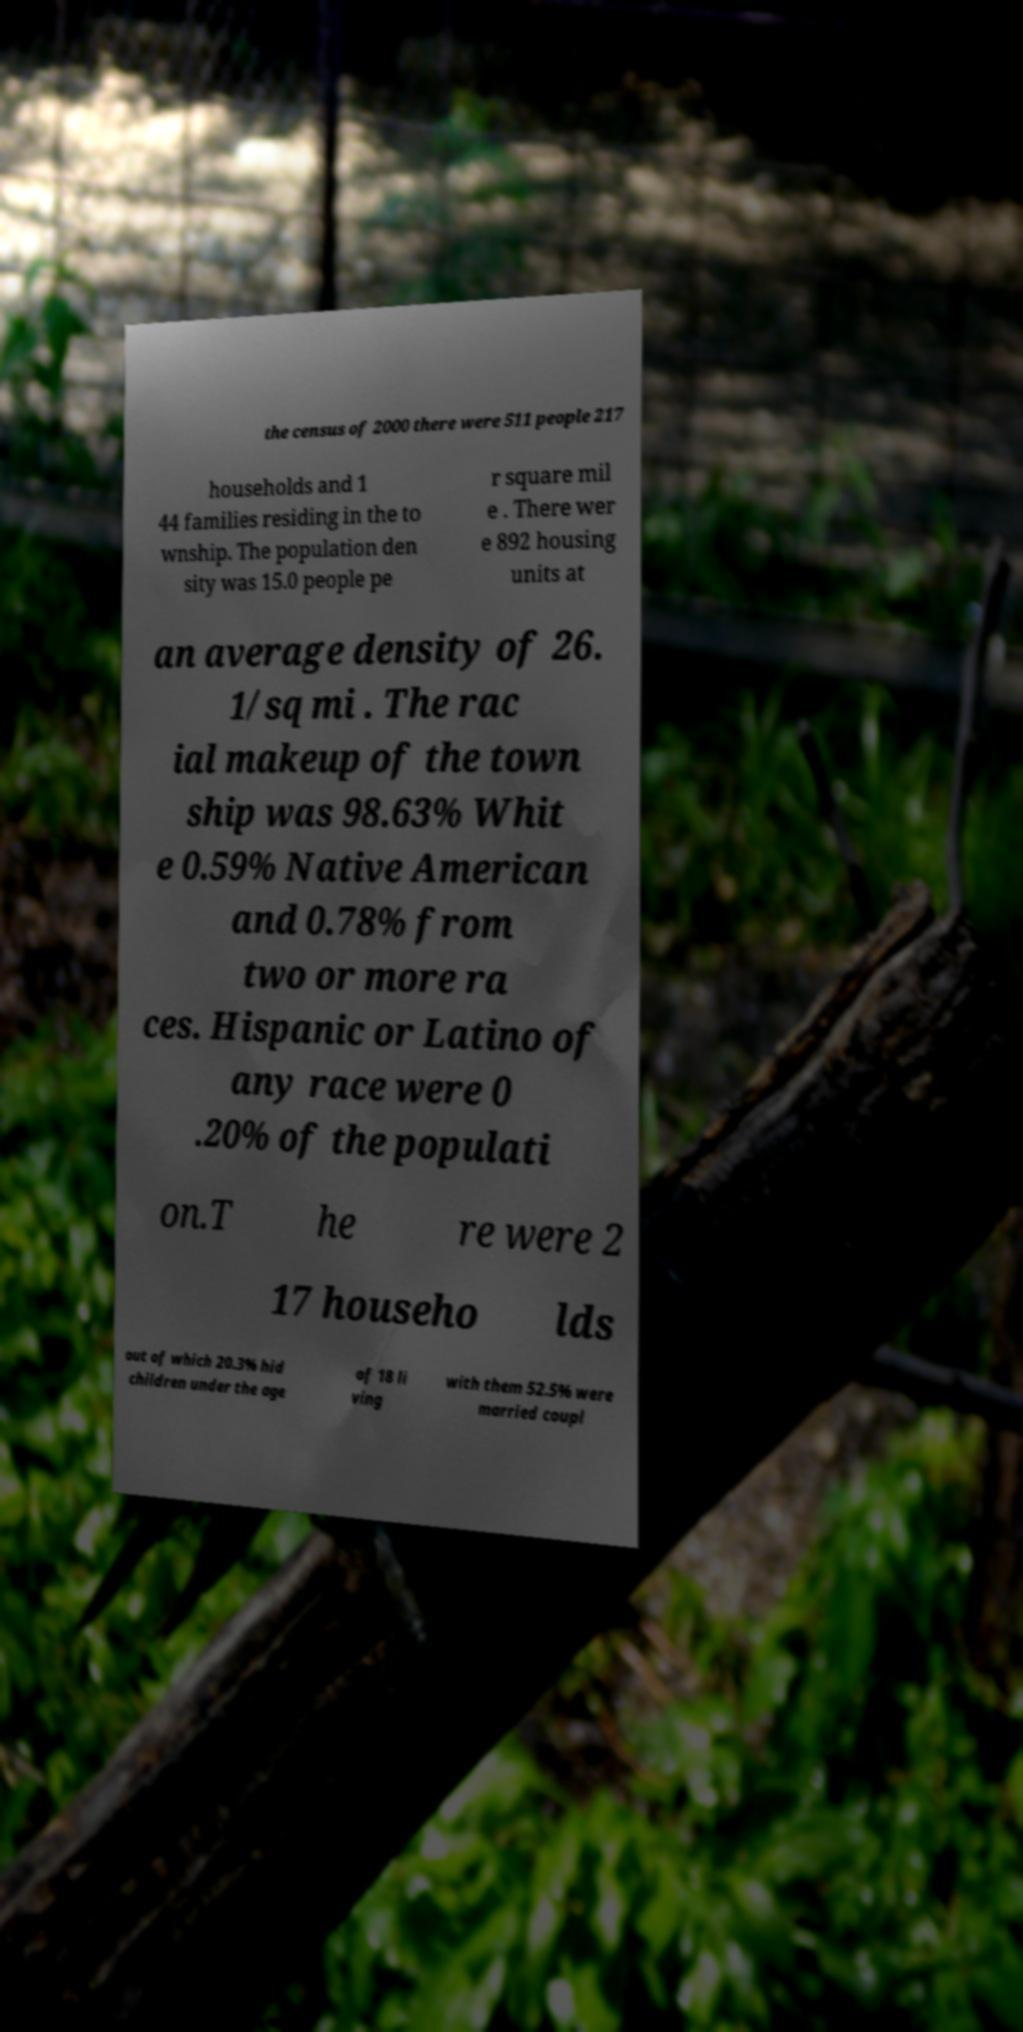For documentation purposes, I need the text within this image transcribed. Could you provide that? the census of 2000 there were 511 people 217 households and 1 44 families residing in the to wnship. The population den sity was 15.0 people pe r square mil e . There wer e 892 housing units at an average density of 26. 1/sq mi . The rac ial makeup of the town ship was 98.63% Whit e 0.59% Native American and 0.78% from two or more ra ces. Hispanic or Latino of any race were 0 .20% of the populati on.T he re were 2 17 househo lds out of which 20.3% hid children under the age of 18 li ving with them 52.5% were married coupl 